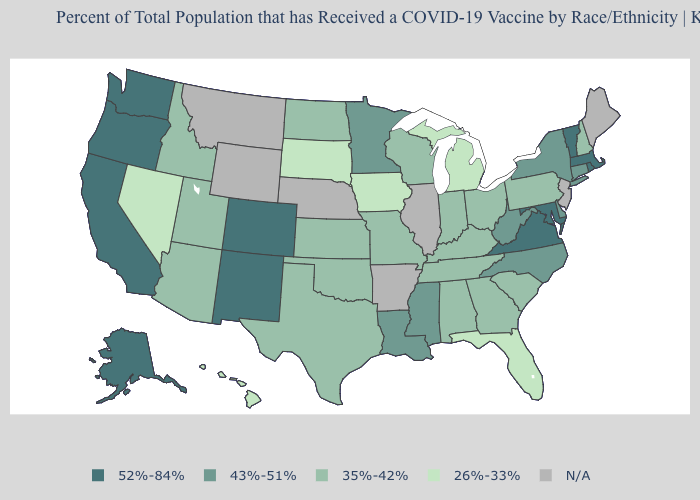Name the states that have a value in the range 43%-51%?
Be succinct. Connecticut, Delaware, Louisiana, Minnesota, Mississippi, New York, North Carolina, West Virginia. What is the lowest value in states that border South Dakota?
Answer briefly. 26%-33%. What is the value of Alabama?
Write a very short answer. 35%-42%. Does Washington have the highest value in the USA?
Keep it brief. Yes. Among the states that border California , does Nevada have the lowest value?
Write a very short answer. Yes. Name the states that have a value in the range 43%-51%?
Be succinct. Connecticut, Delaware, Louisiana, Minnesota, Mississippi, New York, North Carolina, West Virginia. What is the lowest value in the Northeast?
Be succinct. 35%-42%. Among the states that border Rhode Island , which have the lowest value?
Concise answer only. Connecticut. Which states have the lowest value in the USA?
Give a very brief answer. Florida, Hawaii, Iowa, Michigan, Nevada, South Dakota. What is the value of Nebraska?
Keep it brief. N/A. Does Missouri have the lowest value in the USA?
Short answer required. No. What is the highest value in the USA?
Concise answer only. 52%-84%. 